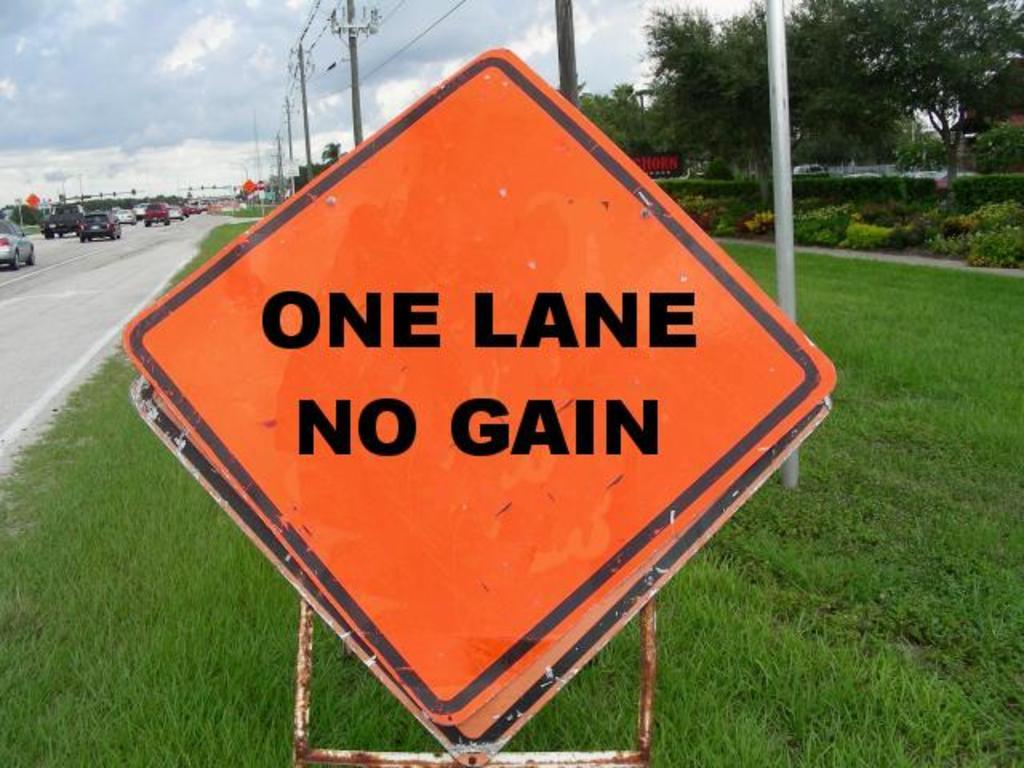<image>
Relay a brief, clear account of the picture shown. DIamond shaped sign which says One Lane No Gain in black letters. 